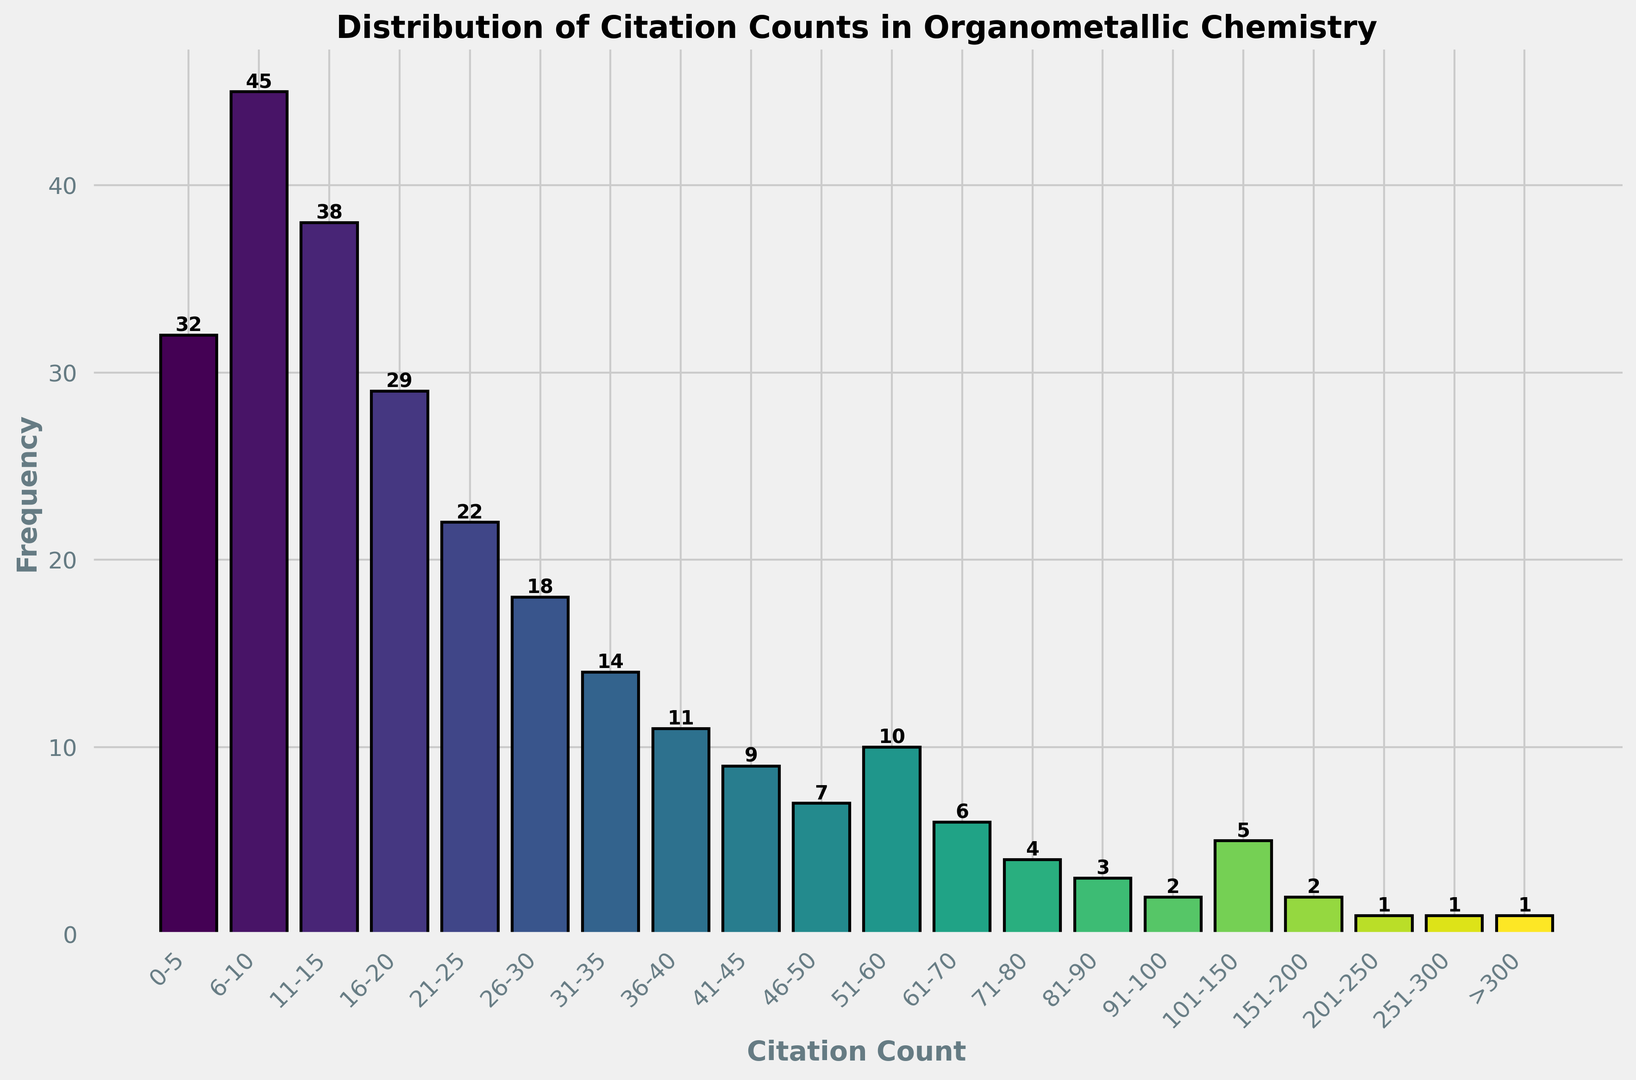What is the frequency of papers cited between 16-20 times? Locate the bar for citation counts 16-20 on the x-axis and read its height, which represents its frequency at 29.
Answer: 29 Which citation count range has the highest frequency of papers? Identify the tallest bar in the histogram. The range 6-10 has the highest frequency at 45.
Answer: 6-10 How many papers are cited more than 100 times? Sum the frequencies of citation ranges above 100: 5 (101-150) + 2 (151-200) + 1 (201-250) + 1 (251-300) + 1 (>300) = 10.
Answer: 10 How does the frequency of 21-25 citation count compare to 46-50 citation count? Compare the heights of the bars for the ranges 21-25 and 46-50; the bar for 21-25 is taller (22) than that for 46-50 (7).
Answer: 21-25 is higher What is the total frequency of papers cited between 0-30 times? Add frequencies for ranges 0-5, 6-10, 11-15, 16-20, 21-25, 26-30: 32 + 45 + 38 + 29 + 22 + 18 = 184.
Answer: 184 What is the frequency of paper citations within the range 101-150? Locate the bar for the 101-150 citation count range and read the height, which is 5.
Answer: 5 Compare the combined frequency of papers cited in the ranges 51-60 and 71-80 to the combined frequency of papers cited in the ranges 81-90 and 91-100. Which is higher? Sum the frequencies for each pair: 51-60 (10) + 71-80 (4) = 14; 81-90 (3) + 91-100 (2) = 5. 14 is higher than 5.
Answer: 51-60 and 71-80 are higher What is the average frequency of papers cited in the ranges 31-70? Sum the frequencies for ranges 31-35, 36-40, 41-45, 46-50, 51-60, 61-70 and divide by the number of ranges: (14 + 11 + 9 + 7 + 10 + 6) / 6 = 57/6 = 9.5.
Answer: 9.5 What color represents the highest frequency range on the histogram? Identify the color of the bar with the highest frequency; the tallest bar (45) in the range 6-10 has a dark green color.
Answer: Dark green 